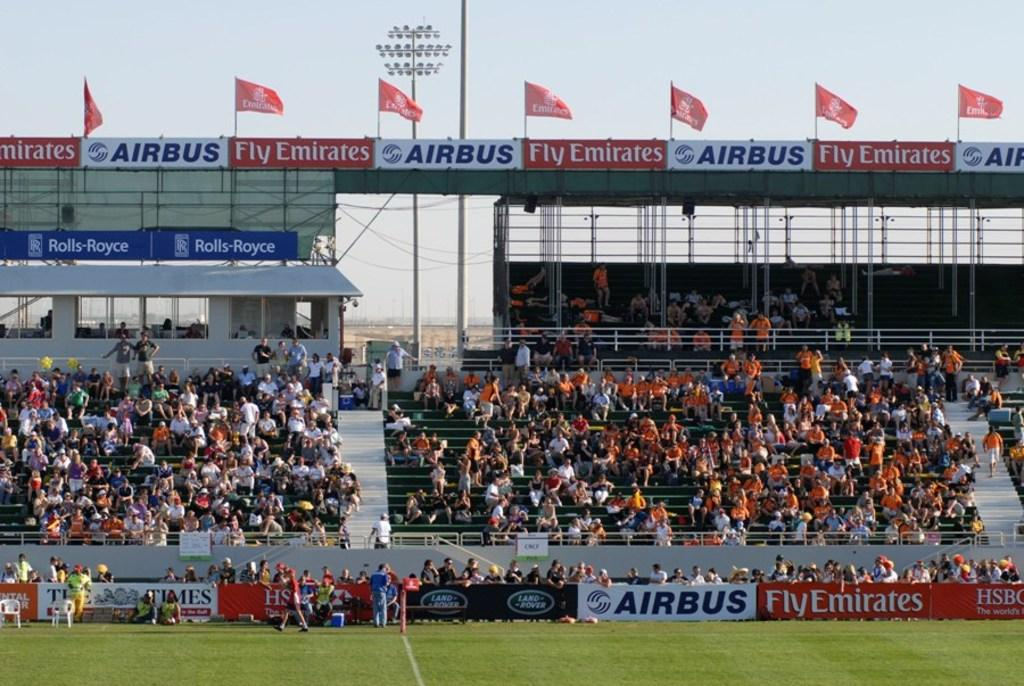Provide a one-sentence caption for the provided image. Emirates and Airbus are the main sponsors of this stadium. 